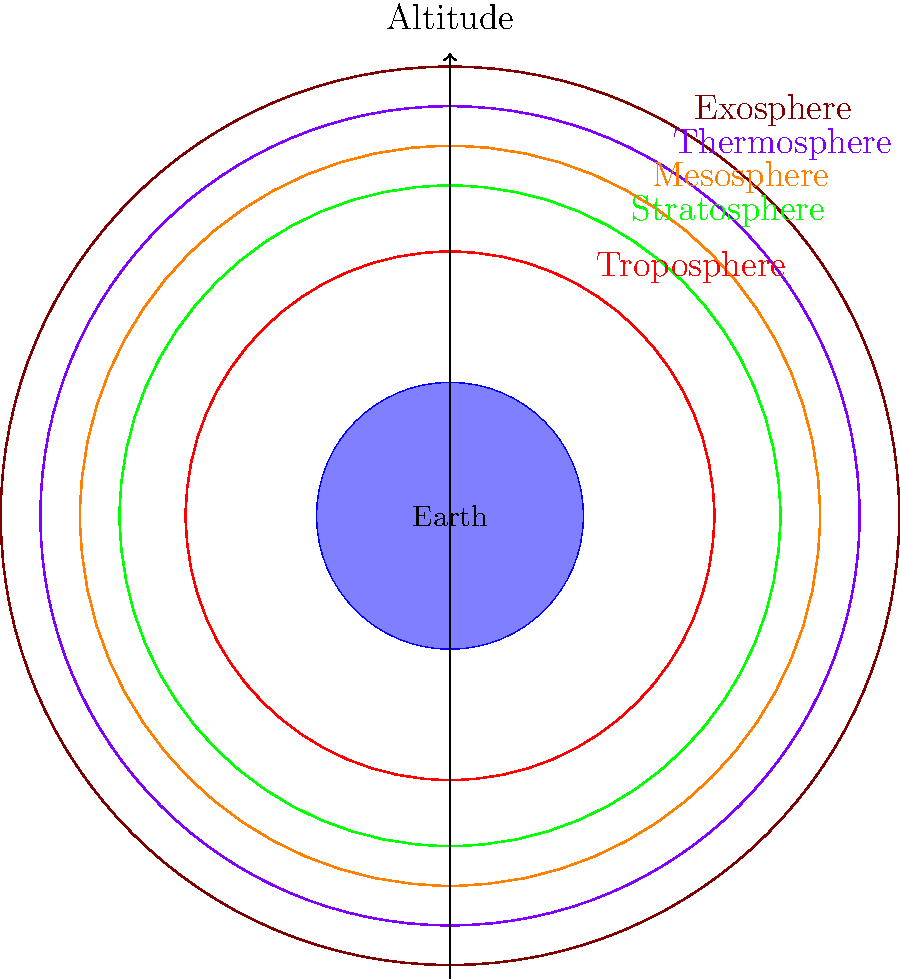Which layer of the Earth's atmosphere, reminiscent of the soaring melodies in Baccara's "Yes Sir, I Can Boogie," extends the highest and transitions into space? To answer this question, let's break down the layers of the Earth's atmosphere from bottom to top:

1. Troposphere: The lowest layer, where most weather phenomena occur.
2. Stratosphere: Above the troposphere, contains the ozone layer.
3. Mesosphere: The third layer, where meteors often burn up.
4. Thermosphere: The fourth layer, where auroras occur.
5. Exosphere: The outermost layer of Earth's atmosphere.

The exosphere is the highest layer of Earth's atmosphere and extends from about 700 km above Earth's surface to as far as 10,000 km, gradually thinning out and merging with interplanetary space. It's named "exosphere" because it's the exit zone from which lighter atmospheric gases can escape into space.

Just as Baccara's music soared to the top of the charts, the exosphere soars highest in our atmosphere, making it the correct answer to this question.
Answer: Exosphere 